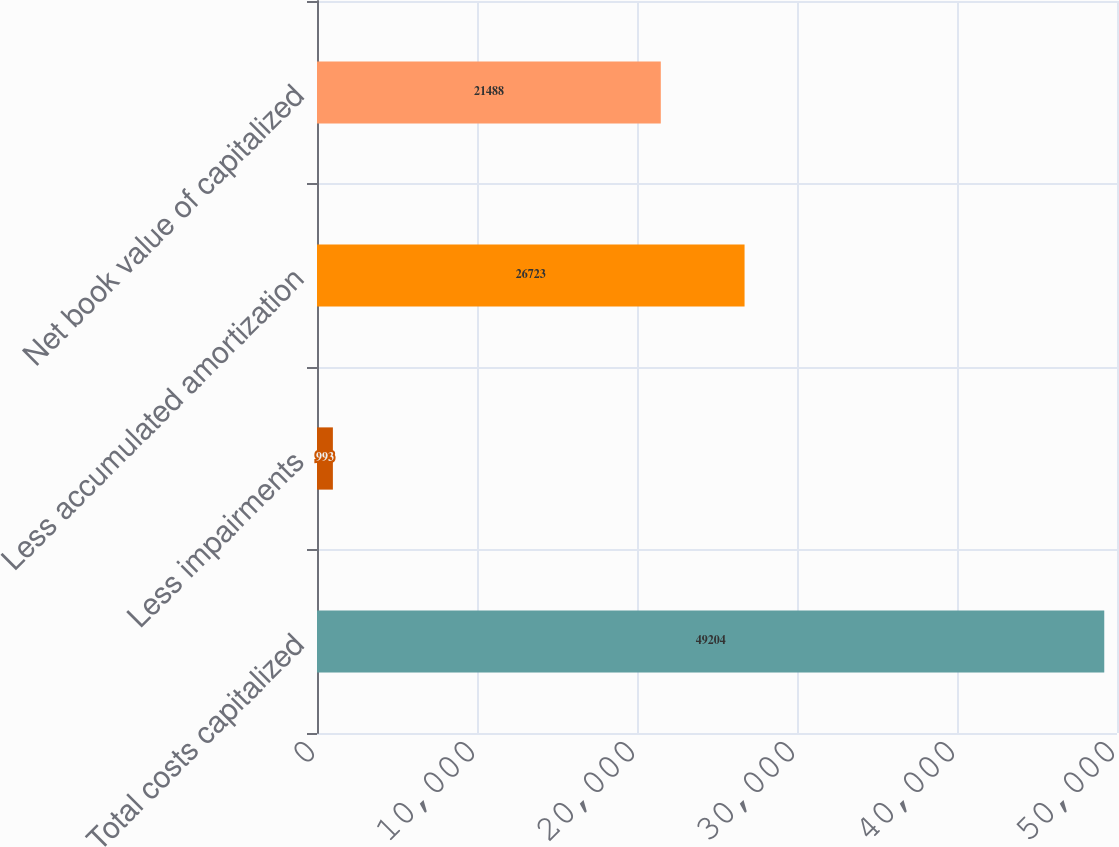Convert chart to OTSL. <chart><loc_0><loc_0><loc_500><loc_500><bar_chart><fcel>Total costs capitalized<fcel>Less impairments<fcel>Less accumulated amortization<fcel>Net book value of capitalized<nl><fcel>49204<fcel>993<fcel>26723<fcel>21488<nl></chart> 